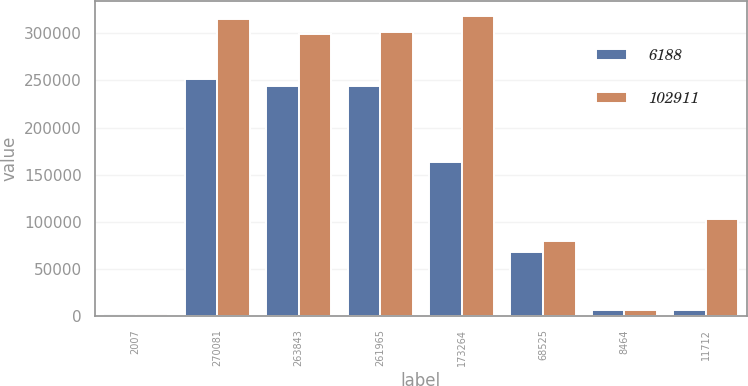Convert chart. <chart><loc_0><loc_0><loc_500><loc_500><stacked_bar_chart><ecel><fcel>2007<fcel>270081<fcel>263843<fcel>261965<fcel>173264<fcel>68525<fcel>8464<fcel>11712<nl><fcel>6188<fcel>2006<fcel>251209<fcel>243819<fcel>244501<fcel>163925<fcel>67829<fcel>6559<fcel>6188<nl><fcel>102911<fcel>2005<fcel>314630<fcel>299316<fcel>301454<fcel>317917<fcel>79692<fcel>6756<fcel>102911<nl></chart> 